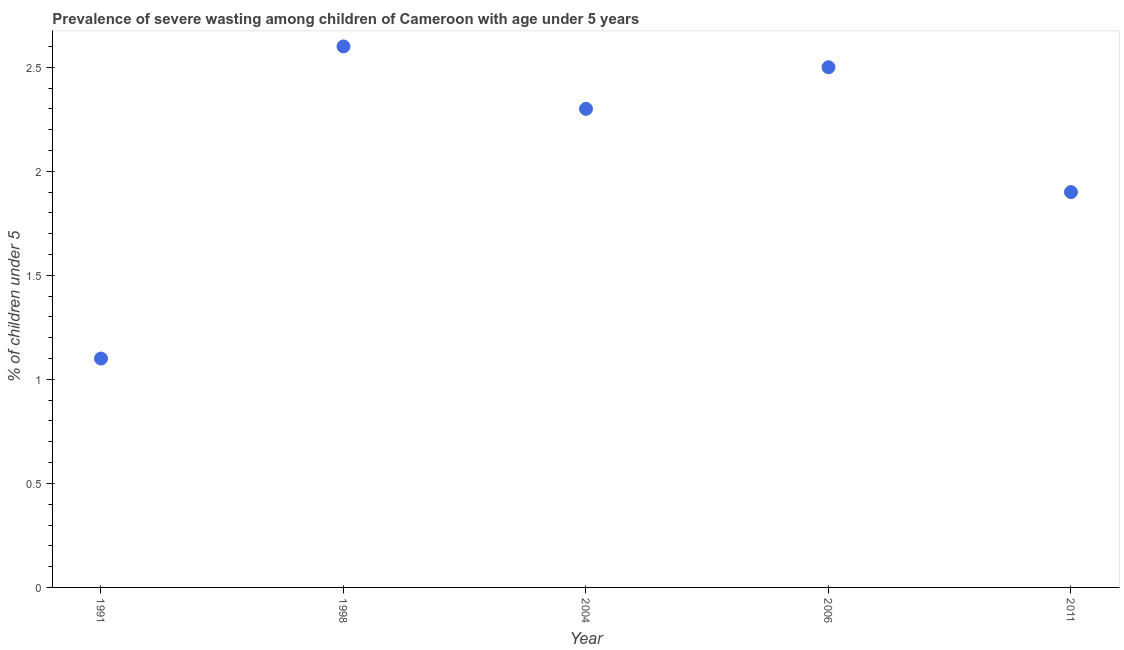What is the prevalence of severe wasting in 2011?
Give a very brief answer. 1.9. Across all years, what is the maximum prevalence of severe wasting?
Your response must be concise. 2.6. Across all years, what is the minimum prevalence of severe wasting?
Ensure brevity in your answer.  1.1. In which year was the prevalence of severe wasting maximum?
Your answer should be very brief. 1998. In which year was the prevalence of severe wasting minimum?
Provide a short and direct response. 1991. What is the sum of the prevalence of severe wasting?
Offer a very short reply. 10.4. What is the difference between the prevalence of severe wasting in 2006 and 2011?
Your answer should be compact. 0.6. What is the average prevalence of severe wasting per year?
Ensure brevity in your answer.  2.08. What is the median prevalence of severe wasting?
Your answer should be very brief. 2.3. In how many years, is the prevalence of severe wasting greater than 1 %?
Provide a short and direct response. 5. What is the ratio of the prevalence of severe wasting in 1998 to that in 2004?
Provide a short and direct response. 1.13. Is the difference between the prevalence of severe wasting in 1998 and 2011 greater than the difference between any two years?
Give a very brief answer. No. What is the difference between the highest and the second highest prevalence of severe wasting?
Give a very brief answer. 0.1. Is the sum of the prevalence of severe wasting in 2004 and 2011 greater than the maximum prevalence of severe wasting across all years?
Give a very brief answer. Yes. What is the difference between the highest and the lowest prevalence of severe wasting?
Offer a terse response. 1.5. How many dotlines are there?
Offer a terse response. 1. Are the values on the major ticks of Y-axis written in scientific E-notation?
Make the answer very short. No. Does the graph contain any zero values?
Give a very brief answer. No. Does the graph contain grids?
Your response must be concise. No. What is the title of the graph?
Ensure brevity in your answer.  Prevalence of severe wasting among children of Cameroon with age under 5 years. What is the label or title of the Y-axis?
Your response must be concise.  % of children under 5. What is the  % of children under 5 in 1991?
Your answer should be very brief. 1.1. What is the  % of children under 5 in 1998?
Provide a succinct answer. 2.6. What is the  % of children under 5 in 2004?
Your response must be concise. 2.3. What is the  % of children under 5 in 2011?
Keep it short and to the point. 1.9. What is the difference between the  % of children under 5 in 1991 and 1998?
Give a very brief answer. -1.5. What is the difference between the  % of children under 5 in 1991 and 2004?
Your answer should be compact. -1.2. What is the difference between the  % of children under 5 in 1991 and 2011?
Give a very brief answer. -0.8. What is the ratio of the  % of children under 5 in 1991 to that in 1998?
Make the answer very short. 0.42. What is the ratio of the  % of children under 5 in 1991 to that in 2004?
Your answer should be very brief. 0.48. What is the ratio of the  % of children under 5 in 1991 to that in 2006?
Your answer should be very brief. 0.44. What is the ratio of the  % of children under 5 in 1991 to that in 2011?
Provide a short and direct response. 0.58. What is the ratio of the  % of children under 5 in 1998 to that in 2004?
Ensure brevity in your answer.  1.13. What is the ratio of the  % of children under 5 in 1998 to that in 2011?
Keep it short and to the point. 1.37. What is the ratio of the  % of children under 5 in 2004 to that in 2006?
Keep it short and to the point. 0.92. What is the ratio of the  % of children under 5 in 2004 to that in 2011?
Provide a short and direct response. 1.21. What is the ratio of the  % of children under 5 in 2006 to that in 2011?
Ensure brevity in your answer.  1.32. 